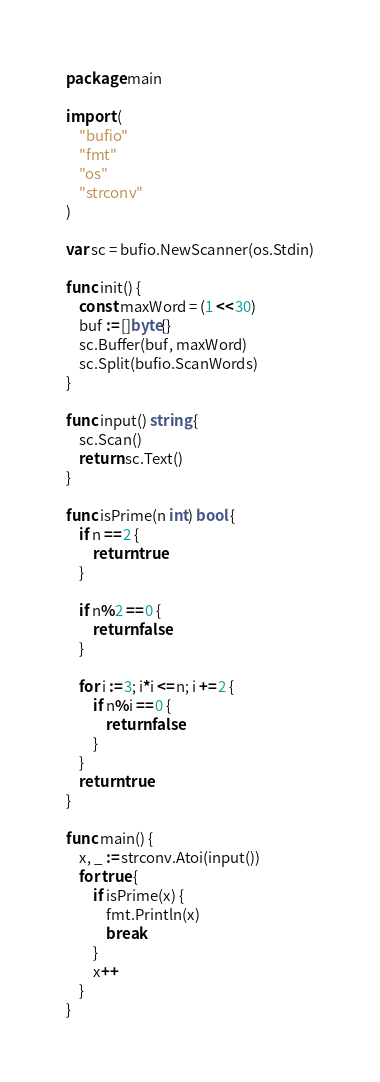<code> <loc_0><loc_0><loc_500><loc_500><_Go_>package main

import (
	"bufio"
	"fmt"
	"os"
	"strconv"
)

var sc = bufio.NewScanner(os.Stdin)

func init() {
	const maxWord = (1 << 30)
	buf := []byte{}
	sc.Buffer(buf, maxWord)
	sc.Split(bufio.ScanWords)
}

func input() string {
	sc.Scan()
	return sc.Text()
}

func isPrime(n int) bool {
	if n == 2 {
		return true
	}

	if n%2 == 0 {
		return false
	}

	for i := 3; i*i <= n; i += 2 {
		if n%i == 0 {
			return false
		}
	}
	return true
}

func main() {
	x, _ := strconv.Atoi(input())
	for true {
		if isPrime(x) {
			fmt.Println(x)
			break
		}
		x++
	}
}
</code> 